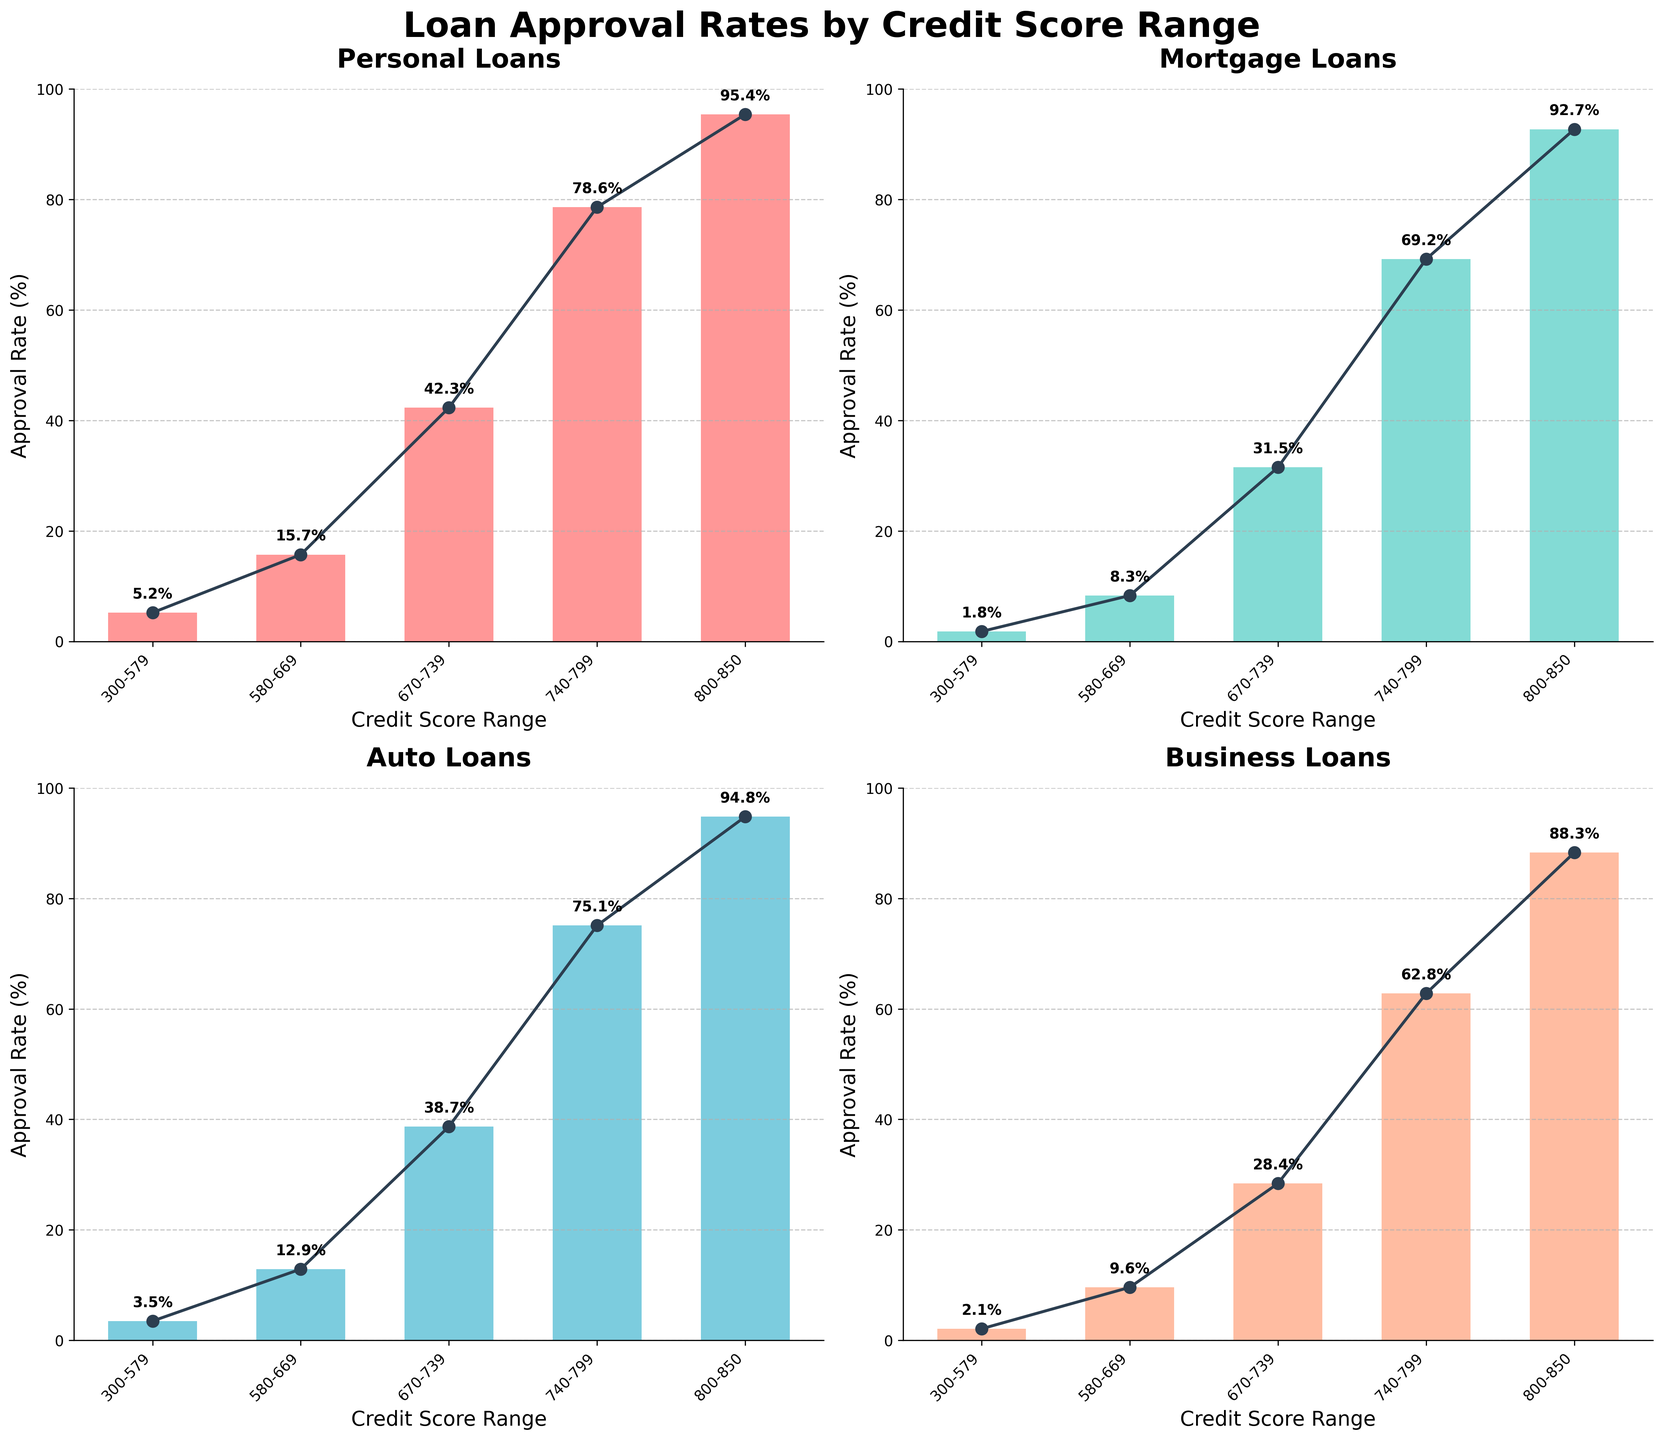Which loan type has the highest approval rate for the credit score range 800-850? Look for the data within the subplots for the 800-850 credit score range and compare the values across all four loan types. Personal Loans have the highest value at 95.4%.
Answer: Personal Loans What is the average approval rate for Mortgage Loans across all credit score ranges? Sum the approval rates for Mortgage Loans: (1.8 + 8.3 + 31.5 + 69.2 + 92.7) = 203.5. Divide this by the number of data points (5). The average is 203.5 / 5 = 40.7.
Answer: 40.7 What is the total approval rate for Personal Loans when summed across all credit score ranges? Add the approval rates for Personal Loans: (5.2 + 15.7 + 42.3 + 78.6 + 95.4) = 237.2.
Answer: 237.2 Which loan type shows the smallest variability in approval rates across different credit score ranges? Assess the range (max - min) of approval rates for each loan type: Personal Loans (95.4 - 5.2 = 90.2), Mortgage Loans (92.7 - 1.8 = 90.9), Auto Loans (94.8 - 3.5 = 91.3), Business Loans (88.3 - 2.1 = 86.2). Business Loans have the smallest range of 86.2.
Answer: Business Loans 